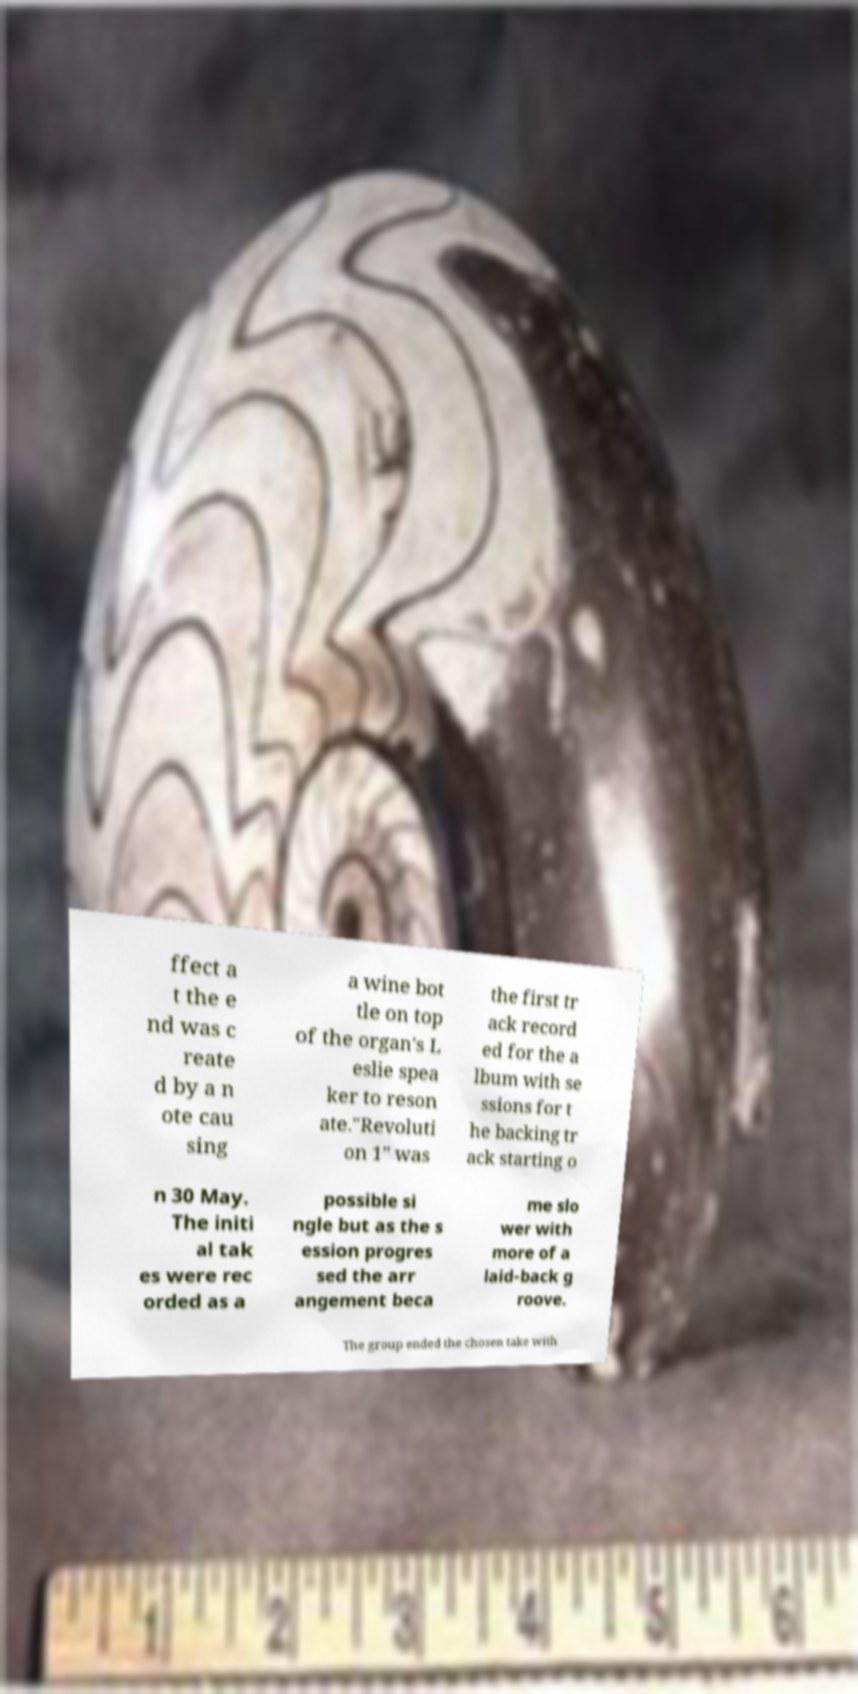Please read and relay the text visible in this image. What does it say? ffect a t the e nd was c reate d by a n ote cau sing a wine bot tle on top of the organ's L eslie spea ker to reson ate."Revoluti on 1" was the first tr ack record ed for the a lbum with se ssions for t he backing tr ack starting o n 30 May. The initi al tak es were rec orded as a possible si ngle but as the s ession progres sed the arr angement beca me slo wer with more of a laid-back g roove. The group ended the chosen take with 